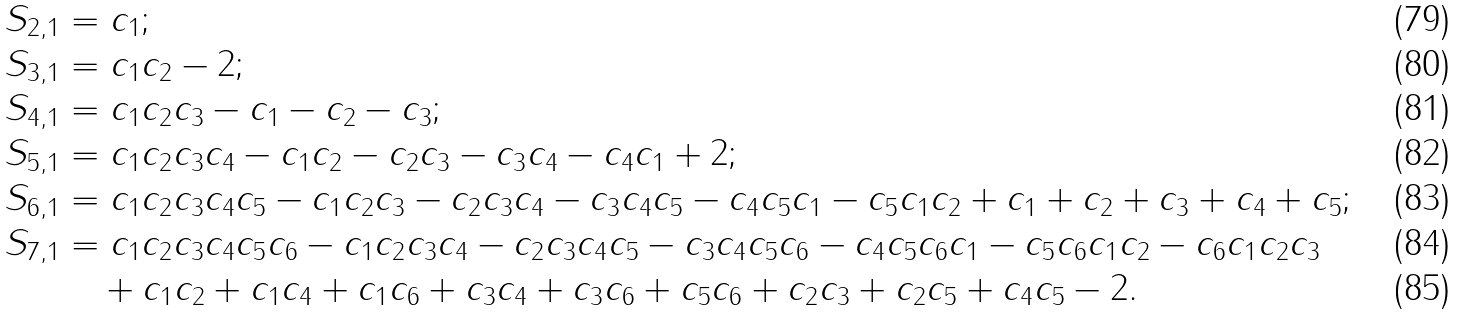<formula> <loc_0><loc_0><loc_500><loc_500>S _ { 2 , 1 } & = c _ { 1 } ; \\ S _ { 3 , 1 } & = c _ { 1 } c _ { 2 } - 2 ; \\ S _ { 4 , 1 } & = c _ { 1 } c _ { 2 } c _ { 3 } - c _ { 1 } - c _ { 2 } - c _ { 3 } ; \\ S _ { 5 , 1 } & = c _ { 1 } c _ { 2 } c _ { 3 } c _ { 4 } - c _ { 1 } c _ { 2 } - c _ { 2 } c _ { 3 } - c _ { 3 } c _ { 4 } - c _ { 4 } c _ { 1 } + 2 ; \\ S _ { 6 , 1 } & = c _ { 1 } c _ { 2 } c _ { 3 } c _ { 4 } c _ { 5 } - c _ { 1 } c _ { 2 } c _ { 3 } - c _ { 2 } c _ { 3 } c _ { 4 } - c _ { 3 } c _ { 4 } c _ { 5 } - c _ { 4 } c _ { 5 } c _ { 1 } - c _ { 5 } c _ { 1 } c _ { 2 } + c _ { 1 } + c _ { 2 } + c _ { 3 } + c _ { 4 } + c _ { 5 } ; \\ S _ { 7 , 1 } & = c _ { 1 } c _ { 2 } c _ { 3 } c _ { 4 } c _ { 5 } c _ { 6 } - c _ { 1 } c _ { 2 } c _ { 3 } c _ { 4 } - c _ { 2 } c _ { 3 } c _ { 4 } c _ { 5 } - c _ { 3 } c _ { 4 } c _ { 5 } c _ { 6 } - c _ { 4 } c _ { 5 } c _ { 6 } c _ { 1 } - c _ { 5 } c _ { 6 } c _ { 1 } c _ { 2 } - c _ { 6 } c _ { 1 } c _ { 2 } c _ { 3 } \\ & \quad + c _ { 1 } c _ { 2 } + c _ { 1 } c _ { 4 } + c _ { 1 } c _ { 6 } + c _ { 3 } c _ { 4 } + c _ { 3 } c _ { 6 } + c _ { 5 } c _ { 6 } + c _ { 2 } c _ { 3 } + c _ { 2 } c _ { 5 } + c _ { 4 } c _ { 5 } - 2 .</formula> 